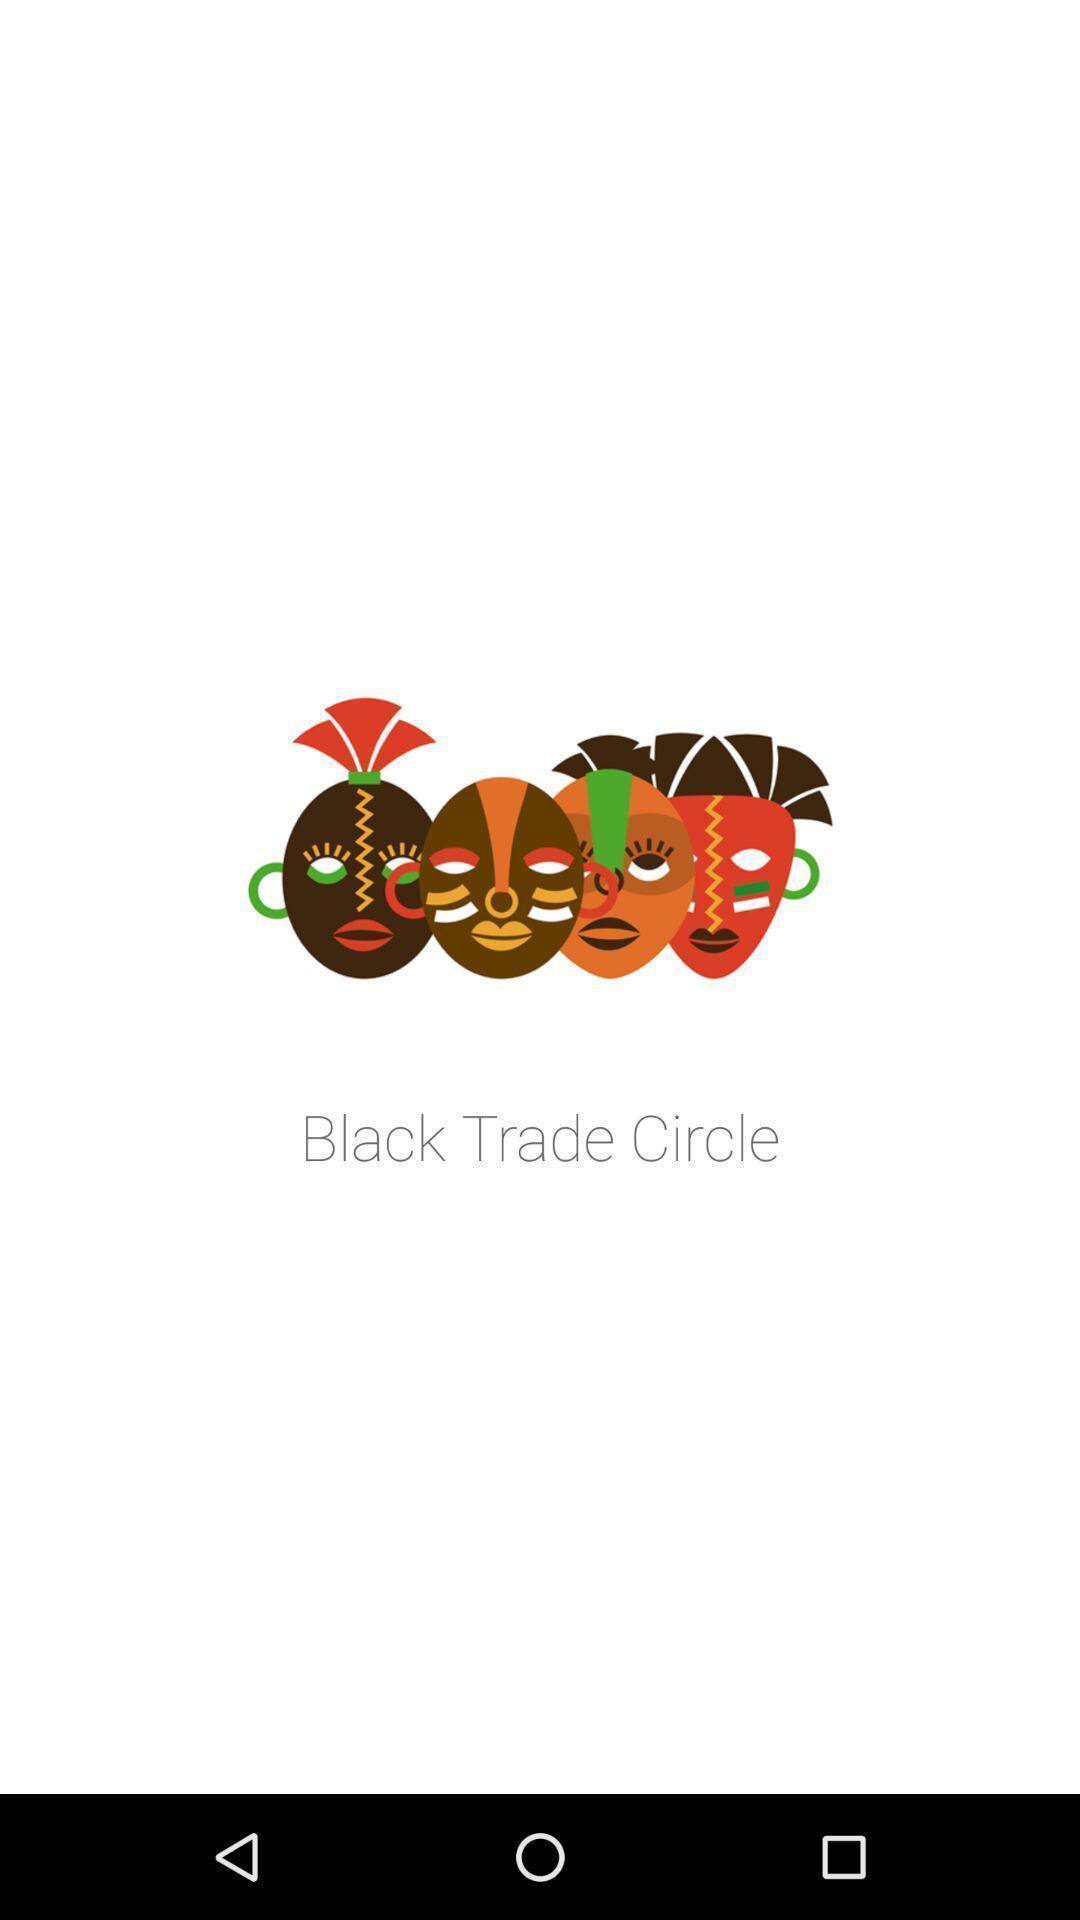Provide a textual representation of this image. Screen shows various images. 